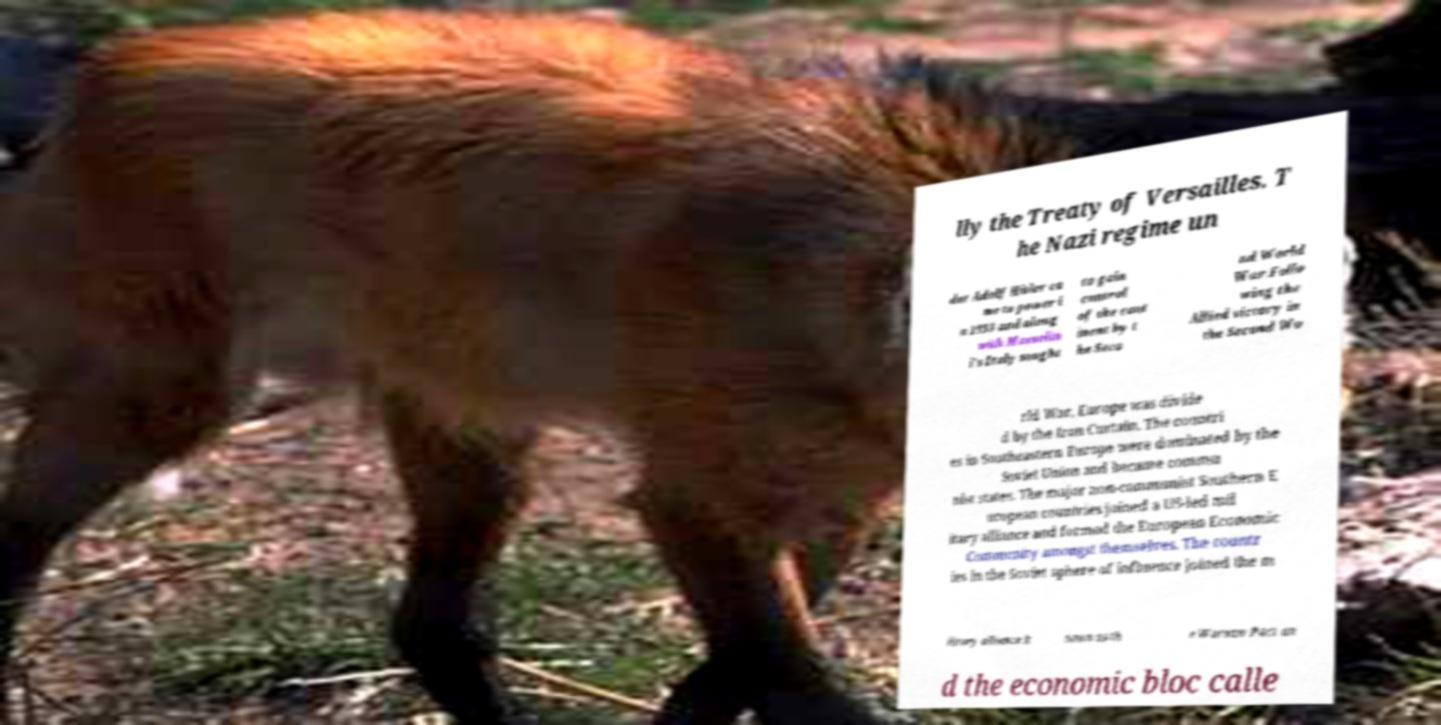What messages or text are displayed in this image? I need them in a readable, typed format. lly the Treaty of Versailles. T he Nazi regime un der Adolf Hitler ca me to power i n 1933 and along with Mussolin i's Italy sought to gain control of the cont inent by t he Seco nd World War.Follo wing the Allied victory in the Second Wo rld War, Europe was divide d by the Iron Curtain. The countri es in Southeastern Europe were dominated by the Soviet Union and became commu nist states. The major non-communist Southern E uropean countries joined a US-led mil itary alliance and formed the European Economic Community amongst themselves. The countr ies in the Soviet sphere of influence joined the m ilitary alliance k nown as th e Warsaw Pact an d the economic bloc calle 